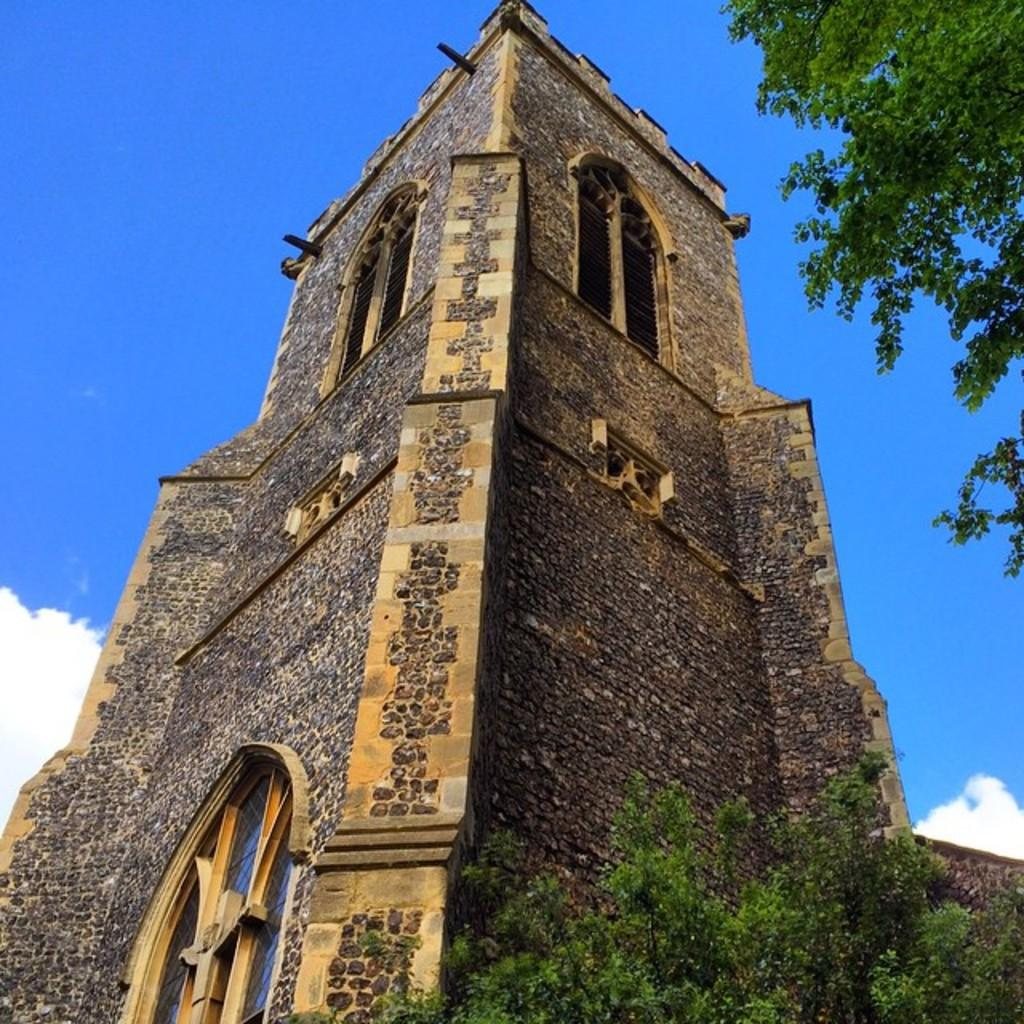What type of structure can be seen in the image? There is a wall in the image. Are there any openings in the wall? Yes, there are windows in the image. What can be seen outside the windows? A tree and plants are visible in the image. What is visible in the background of the image? The sky is visible in the background of the image. What is the condition of the sky in the image? Clouds are present in the sky. What type of event is taking place on the island in the image? There is no island present in the image; it features a wall, windows, a tree, plants, and a sky with clouds. 